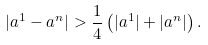<formula> <loc_0><loc_0><loc_500><loc_500>| a ^ { 1 } - a ^ { n } | > \frac { 1 } { 4 } \left ( | a ^ { 1 } | + | a ^ { n } | \right ) .</formula> 